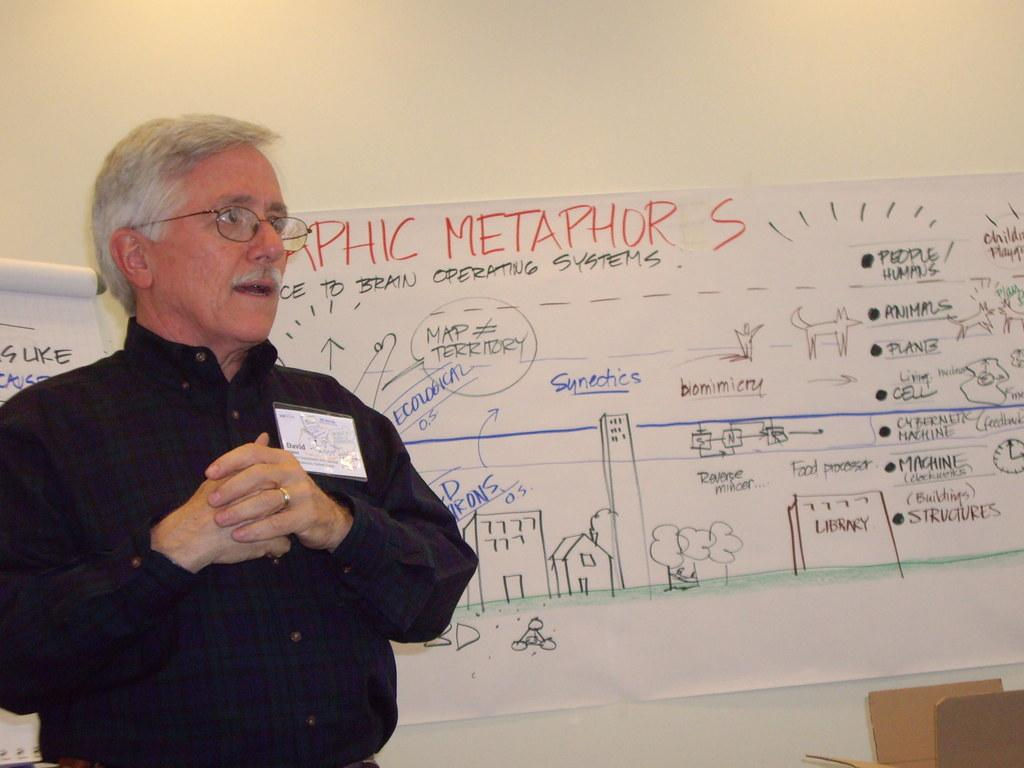<image>
Write a terse but informative summary of the picture. Graphic metaphors are explained by a man next to the sheet 